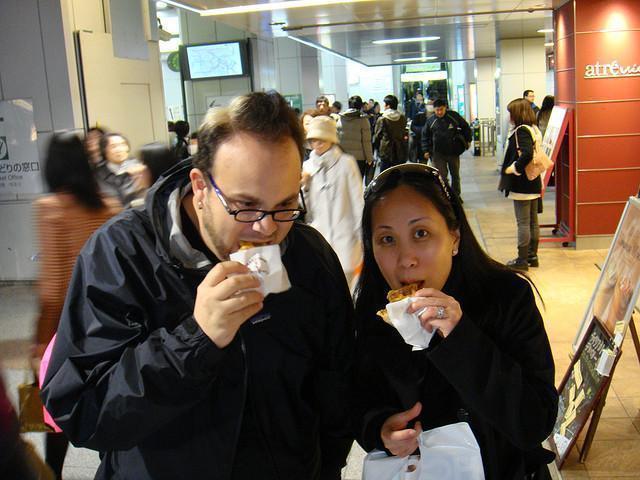Why did this couple take a break?
Choose the correct response and explain in the format: 'Answer: answer
Rationale: rationale.'
Options: Hunger, bathroom, work rule, thirst. Answer: hunger.
Rationale: The couple is hungry. 